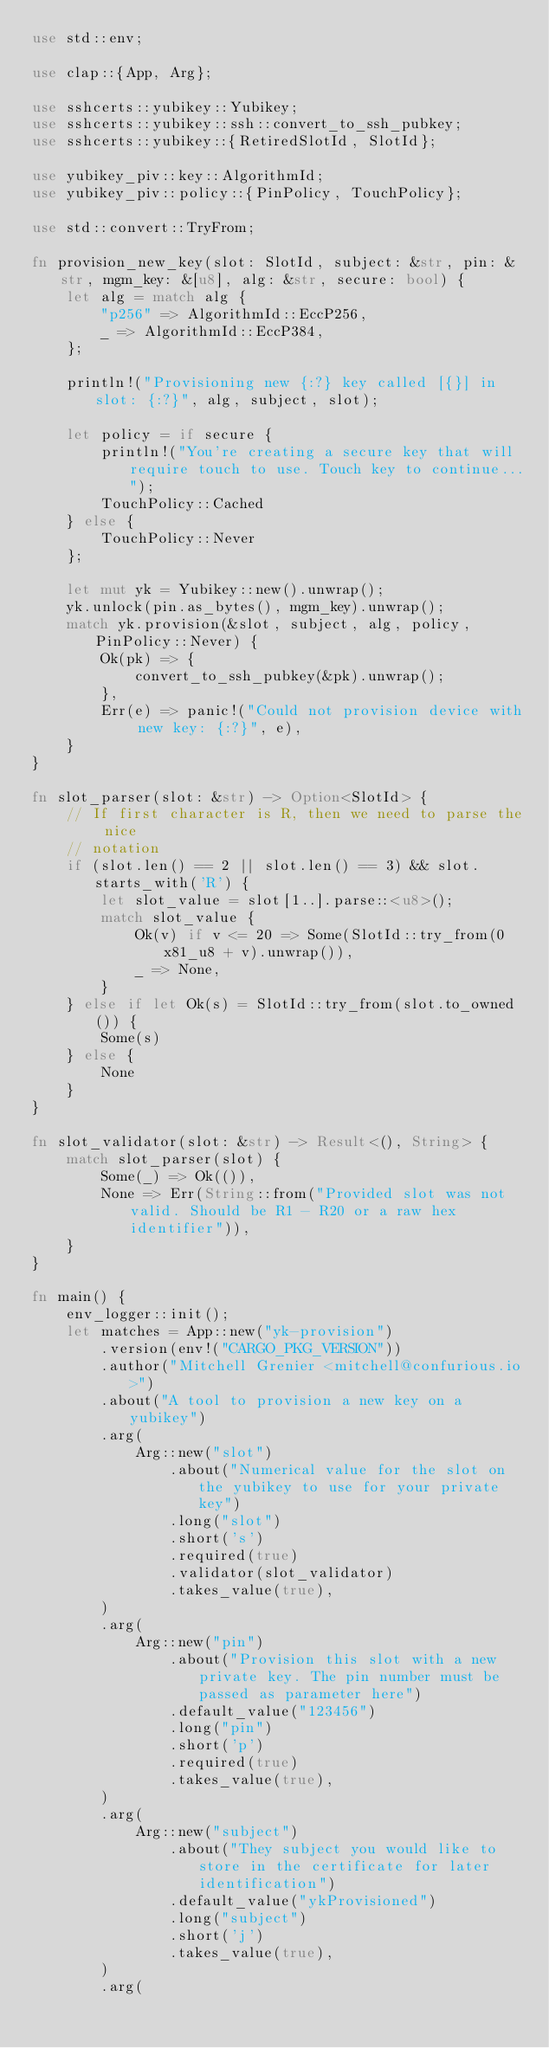<code> <loc_0><loc_0><loc_500><loc_500><_Rust_>use std::env;

use clap::{App, Arg};

use sshcerts::yubikey::Yubikey;
use sshcerts::yubikey::ssh::convert_to_ssh_pubkey;
use sshcerts::yubikey::{RetiredSlotId, SlotId};

use yubikey_piv::key::AlgorithmId;
use yubikey_piv::policy::{PinPolicy, TouchPolicy};

use std::convert::TryFrom;

fn provision_new_key(slot: SlotId, subject: &str, pin: &str, mgm_key: &[u8], alg: &str, secure: bool) {
    let alg = match alg {
        "p256" => AlgorithmId::EccP256,
        _ => AlgorithmId::EccP384,
    };

    println!("Provisioning new {:?} key called [{}] in slot: {:?}", alg, subject, slot);

    let policy = if secure {
        println!("You're creating a secure key that will require touch to use. Touch key to continue...");
        TouchPolicy::Cached
    } else {
        TouchPolicy::Never
    };

    let mut yk = Yubikey::new().unwrap();
    yk.unlock(pin.as_bytes(), mgm_key).unwrap();
    match yk.provision(&slot, subject, alg, policy, PinPolicy::Never) {
        Ok(pk) => {
            convert_to_ssh_pubkey(&pk).unwrap();
        },
        Err(e) => panic!("Could not provision device with new key: {:?}", e),
    }
}

fn slot_parser(slot: &str) -> Option<SlotId> {
    // If first character is R, then we need to parse the nice
    // notation
    if (slot.len() == 2 || slot.len() == 3) && slot.starts_with('R') {
        let slot_value = slot[1..].parse::<u8>();
        match slot_value {
            Ok(v) if v <= 20 => Some(SlotId::try_from(0x81_u8 + v).unwrap()),
            _ => None,
        }
    } else if let Ok(s) = SlotId::try_from(slot.to_owned()) {
        Some(s)
    } else {
        None
    }
}

fn slot_validator(slot: &str) -> Result<(), String> {
    match slot_parser(slot) {
        Some(_) => Ok(()),
        None => Err(String::from("Provided slot was not valid. Should be R1 - R20 or a raw hex identifier")),
    }
}

fn main() {
    env_logger::init();
    let matches = App::new("yk-provision")
        .version(env!("CARGO_PKG_VERSION"))
        .author("Mitchell Grenier <mitchell@confurious.io>")
        .about("A tool to provision a new key on a yubikey")
        .arg(
            Arg::new("slot")
                .about("Numerical value for the slot on the yubikey to use for your private key")
                .long("slot")
                .short('s')
                .required(true)
                .validator(slot_validator)
                .takes_value(true),
        )
        .arg(
            Arg::new("pin")
                .about("Provision this slot with a new private key. The pin number must be passed as parameter here")
                .default_value("123456")
                .long("pin")
                .short('p')
                .required(true)
                .takes_value(true),
        )
        .arg(
            Arg::new("subject")
                .about("They subject you would like to store in the certificate for later identification")
                .default_value("ykProvisioned")
                .long("subject")
                .short('j')
                .takes_value(true),
        )
        .arg(</code> 